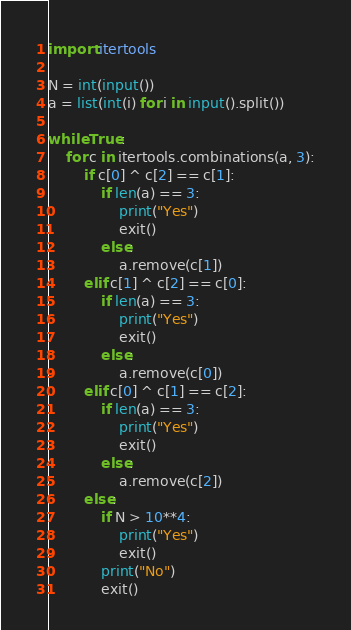Convert code to text. <code><loc_0><loc_0><loc_500><loc_500><_Python_>import itertools

N = int(input())
a = list(int(i) for i in input().split())

while True:
    for c in itertools.combinations(a, 3):
        if c[0] ^ c[2] == c[1]:
            if len(a) == 3:
                print("Yes")
                exit()
            else:
                a.remove(c[1])
        elif c[1] ^ c[2] == c[0]:
            if len(a) == 3:
                print("Yes")
                exit()
            else:
                a.remove(c[0])
        elif c[0] ^ c[1] == c[2]:
            if len(a) == 3:
                print("Yes")
                exit()
            else:
                a.remove(c[2])
        else:
            if N > 10**4:
                print("Yes")
                exit()
            print("No")
            exit()</code> 